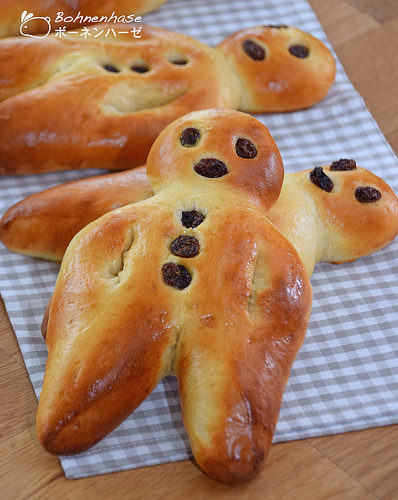<image>
Can you confirm if the raisin is in the bread? Yes. The raisin is contained within or inside the bread, showing a containment relationship. Is there a bread on the table? Yes. Looking at the image, I can see the bread is positioned on top of the table, with the table providing support. 